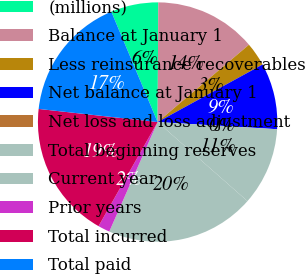<chart> <loc_0><loc_0><loc_500><loc_500><pie_chart><fcel>(millions)<fcel>Balance at January 1<fcel>Less reinsurance recoverables<fcel>Net balance at January 1<fcel>Net loss and loss adjustment<fcel>Total beginning reserves<fcel>Current year<fcel>Prior years<fcel>Total incurred<fcel>Total paid<nl><fcel>6.41%<fcel>13.73%<fcel>3.2%<fcel>8.93%<fcel>0.0%<fcel>10.53%<fcel>20.13%<fcel>1.6%<fcel>18.53%<fcel>16.93%<nl></chart> 